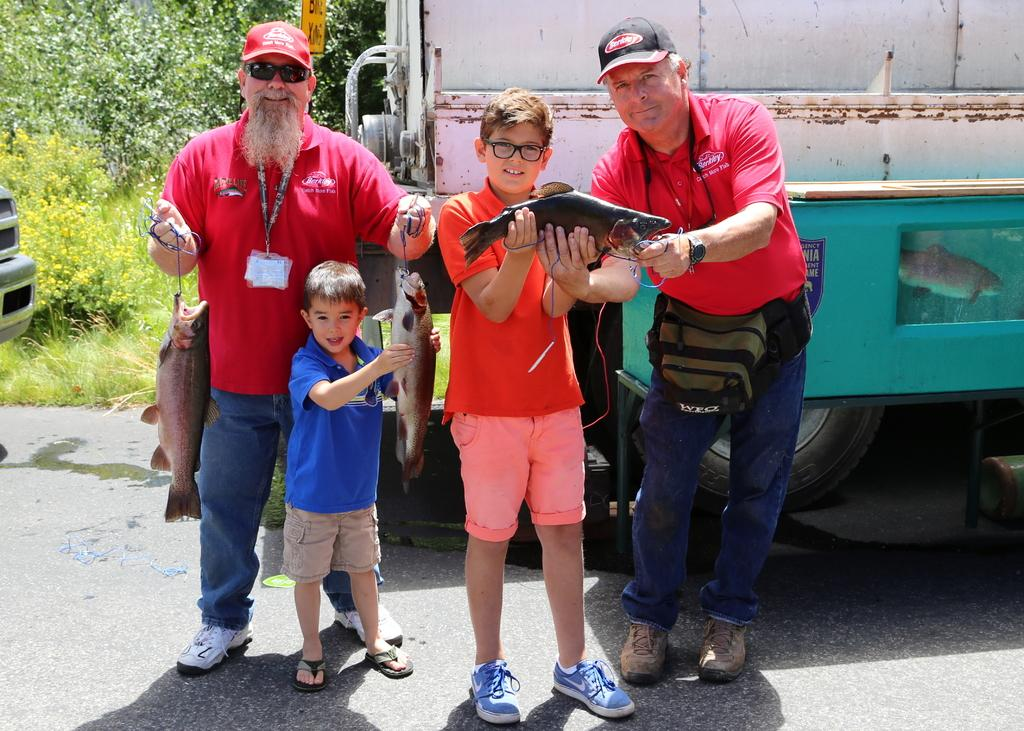What are the people in the foreground of the image doing? The people in the foreground of the image are holding fish in their hands. What can be seen in the background of the image? There are vehicles and greenery in the background of the image. What type of linen is draped over the zebra in the image? There is no linen or zebra present in the image. What time is indicated by the clock in the image? There is no clock present in the image. 